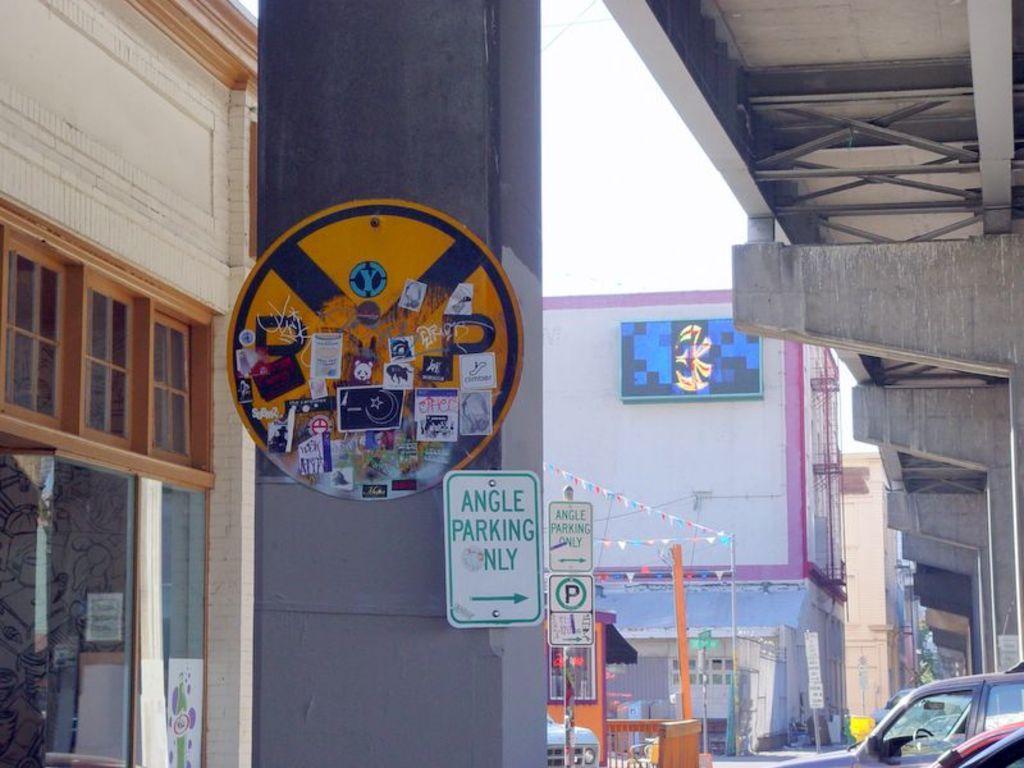Describe this image in one or two sentences. These are the boards, which are attached to a pillar. This looks like a flyover with the pillars. I can see the sign boards, which are attached to a pole. These are the buildings. This looks like a hoarding, which is attached to a building wall. At the bottom right side of the image, I can see the vehicles. 